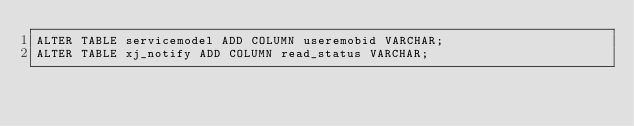<code> <loc_0><loc_0><loc_500><loc_500><_SQL_>ALTER TABLE servicemodel ADD COLUMN useremobid VARCHAR;
ALTER TABLE xj_notify ADD COLUMN read_status VARCHAR;</code> 